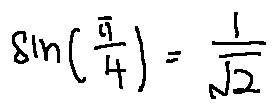<formula> <loc_0><loc_0><loc_500><loc_500>\sin ( \frac { \pi } { 4 } ) = \frac { 1 } { \sqrt { 2 } }</formula> 